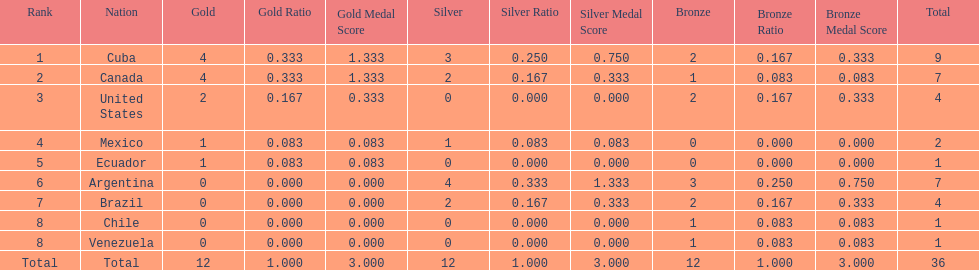Who is ranked #1? Cuba. 